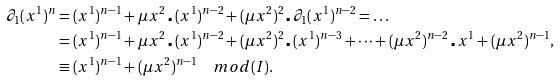<formula> <loc_0><loc_0><loc_500><loc_500>\partial _ { 1 } ( x ^ { 1 } ) ^ { n } & = ( x ^ { 1 } ) ^ { n - 1 } + \mu x ^ { 2 } \centerdot ( x ^ { 1 } ) ^ { n - 2 } + ( \mu x ^ { 2 } ) ^ { 2 } \centerdot \partial _ { 1 } ( x ^ { 1 } ) ^ { n - 2 } = \dots \\ & = ( x ^ { 1 } ) ^ { n - 1 } + \mu x ^ { 2 } \centerdot ( x ^ { 1 } ) ^ { n - 2 } + ( \mu x ^ { 2 } ) ^ { 2 } \centerdot ( x ^ { 1 } ) ^ { n - 3 } + \cdots + ( \mu x ^ { 2 } ) ^ { n - 2 } \centerdot x ^ { 1 } + ( \mu x ^ { 2 } ) ^ { n - 1 } , \\ & \equiv ( x ^ { 1 } ) ^ { n - 1 } + ( \mu x ^ { 2 } ) ^ { n - 1 } \quad m o d ( I ) .</formula> 